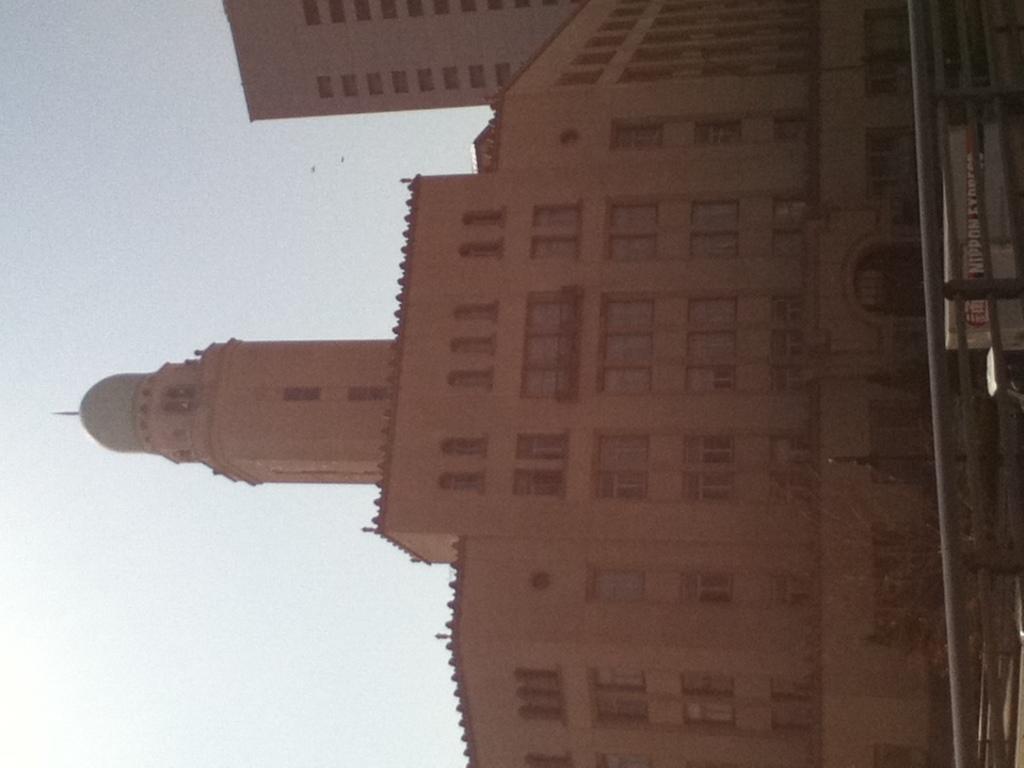How would you summarize this image in a sentence or two? In this image we can see two big buildings, some objects are on the surface, one fence, some poles, one board with some text and at the top there is the sky. 